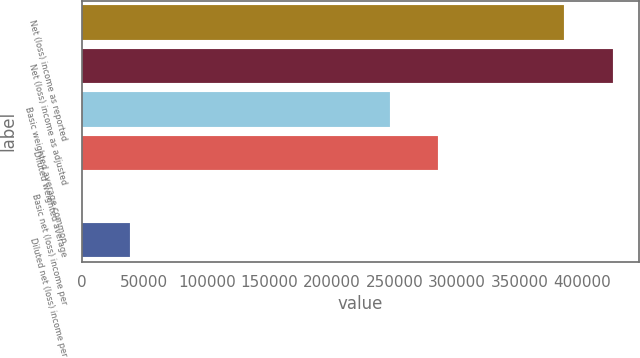<chart> <loc_0><loc_0><loc_500><loc_500><bar_chart><fcel>Net (loss) income as reported<fcel>Net (loss) income as adjusted<fcel>Basic weighted average common<fcel>Diluted weighted average<fcel>Basic net (loss) income per<fcel>Diluted net (loss) income per<nl><fcel>385617<fcel>424179<fcel>245968<fcel>284530<fcel>1.57<fcel>38563.1<nl></chart> 